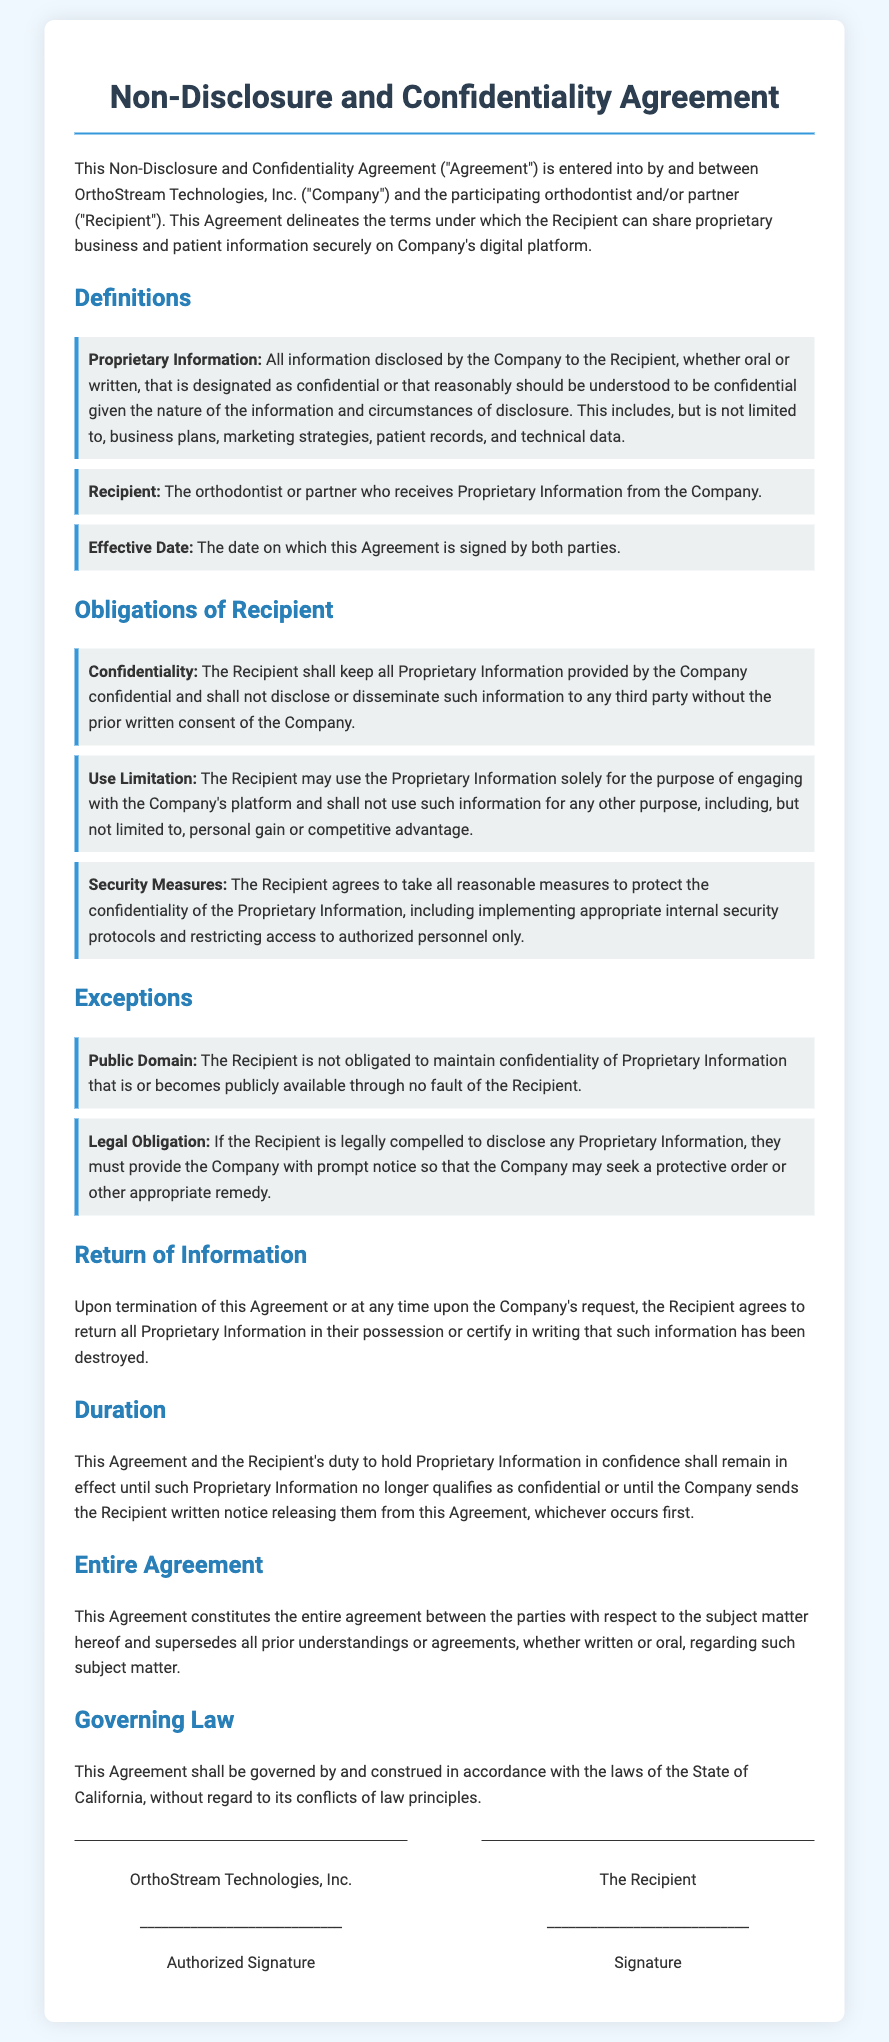What is the name of the company in the Agreement? The name of the company is listed at the beginning of the Agreement as "OrthoStream Technologies, Inc."
Answer: OrthoStream Technologies, Inc What is defined as "Proprietary Information"? The document specifies that Proprietary Information includes information disclosed by the Company that is designated as confidential or understood to be confidential, such as business plans and patient records.
Answer: All information disclosed by the Company What is the obligation of the Recipient regarding confidentiality? The obligation regarding confidentiality requires the Recipient to keep all Proprietary Information confidential and not disclose it to third parties without consent.
Answer: Keep all Proprietary Information confidential What must the Recipient do if required by law to disclose information? If legally compelled to disclose Proprietary Information, the Recipient must provide prompt notice to the Company to allow for protective measures.
Answer: Provide prompt notice to the Company How long does the Agreement remain in effect? The Agreement remains in effect until the Proprietary Information no longer qualifies as confidential or the Company provides a written notice of release.
Answer: Until the Proprietary Information no longer qualifies as confidential What is the Effective Date of the Agreement? The Effective Date is mentioned as the date on which the Agreement is signed by both parties.
Answer: The date on which this Agreement is signed What should the Recipient do with Proprietary Information upon termination of the Agreement? Upon termination or at the Company's request, the Recipient must return all Proprietary Information or certify that it has been destroyed.
Answer: Return all Proprietary Information What governs this Agreement? The legal jurisdiction that governs the Agreement is specified as the State of California.
Answer: The State of California What is the primary purpose for which Proprietary Information can be used? The document states that Proprietary Information may only be used for engaging with the Company's platform, not for personal gain or competitive advantage.
Answer: Engaging with the Company's platform 